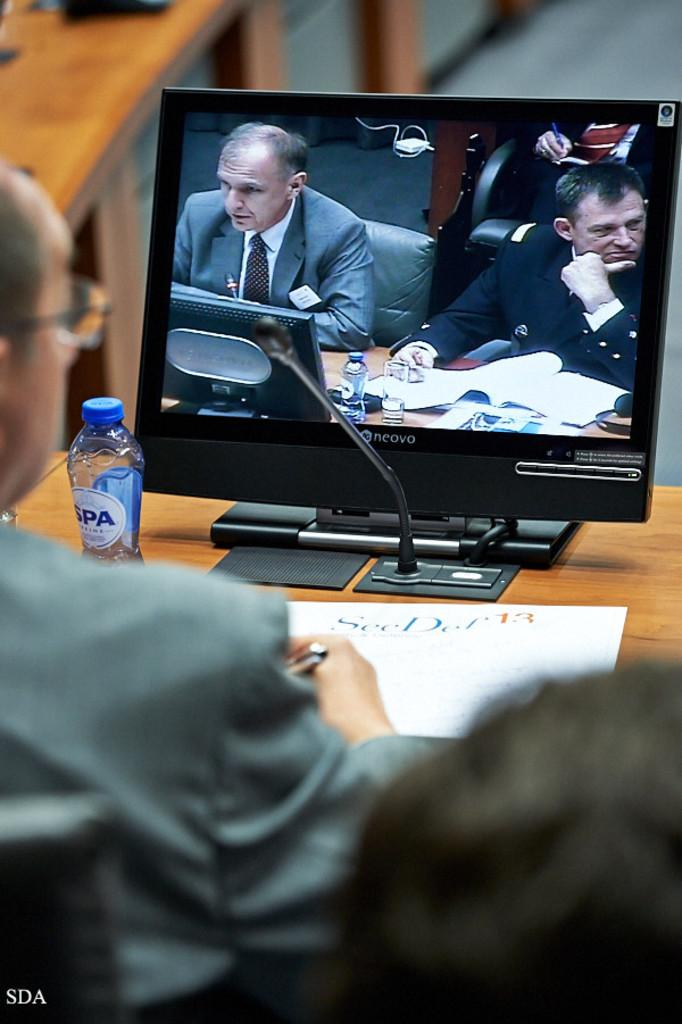How many people are in the image? There are two persons in the image. What are they doing in the image? They are sitting together. Where are they sitting in relation to the table? They are in front of a table. What is the purpose of the screen in the image? The screen is part of a system, but the specific purpose is not mentioned in the facts. What type of books are the persons reading in the image? There are no books present in the image. How does the person in front of the screen react to a joke? There is no indication of laughter or jokes in the image. 